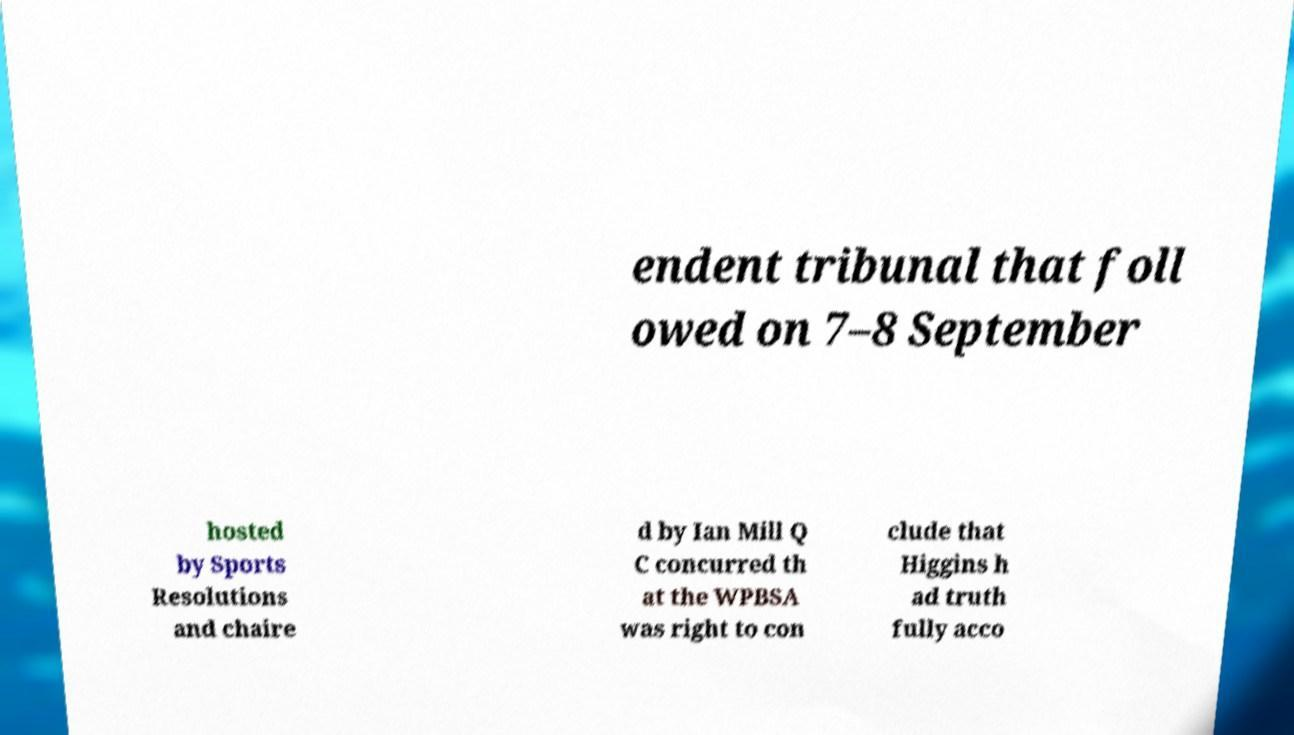I need the written content from this picture converted into text. Can you do that? endent tribunal that foll owed on 7–8 September hosted by Sports Resolutions and chaire d by Ian Mill Q C concurred th at the WPBSA was right to con clude that Higgins h ad truth fully acco 